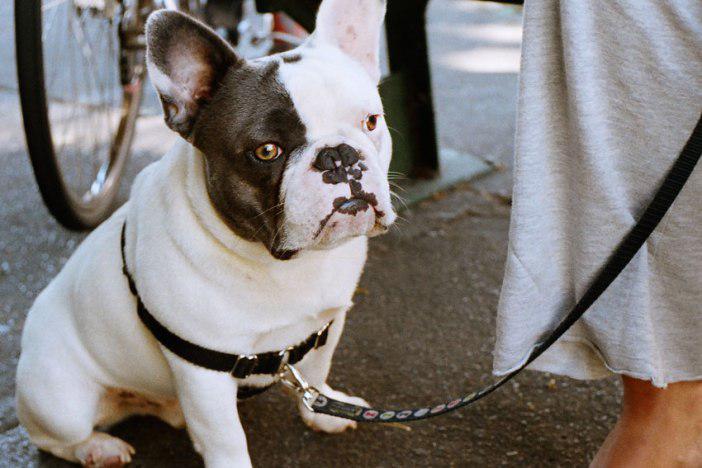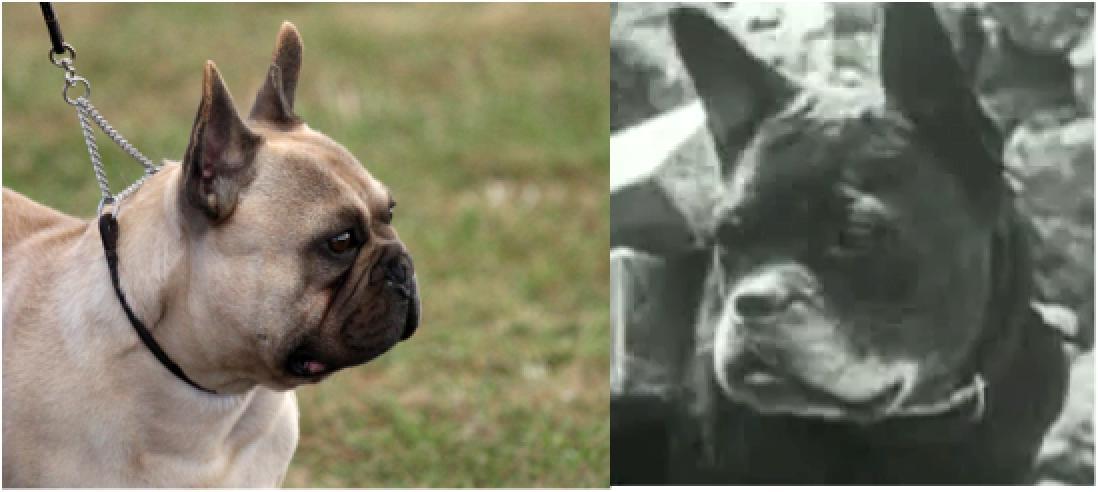The first image is the image on the left, the second image is the image on the right. For the images displayed, is the sentence "At least one of the images features dogs that are outside." factually correct? Answer yes or no. Yes. The first image is the image on the left, the second image is the image on the right. Examine the images to the left and right. Is the description "There are five puppies in the right image." accurate? Answer yes or no. No. 